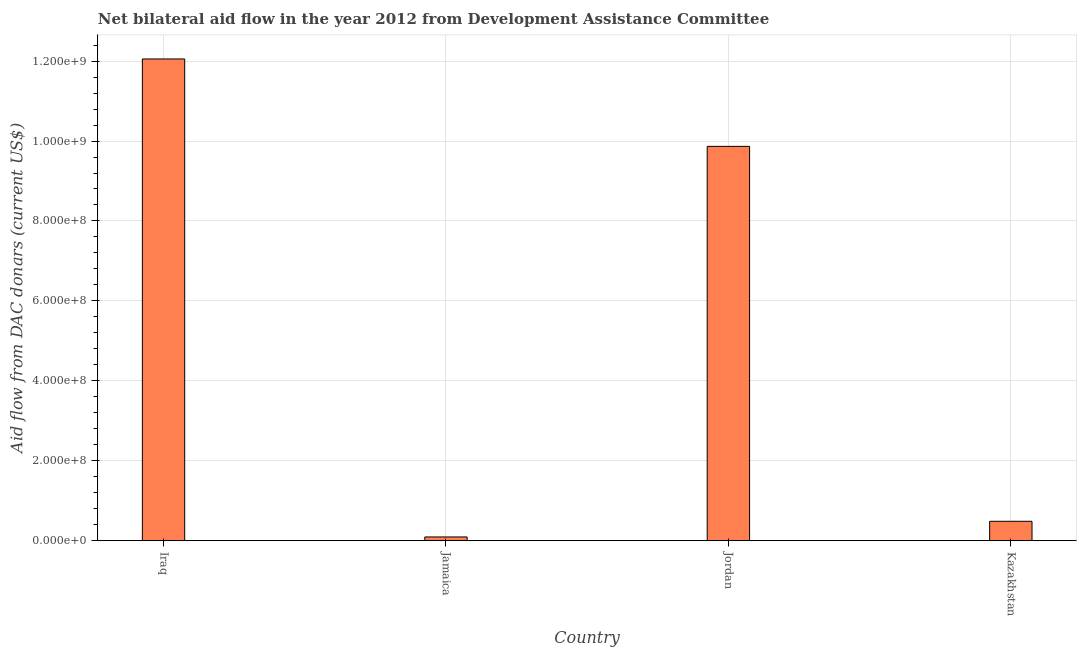Does the graph contain any zero values?
Your response must be concise. No. Does the graph contain grids?
Your response must be concise. Yes. What is the title of the graph?
Give a very brief answer. Net bilateral aid flow in the year 2012 from Development Assistance Committee. What is the label or title of the Y-axis?
Your answer should be very brief. Aid flow from DAC donars (current US$). What is the net bilateral aid flows from dac donors in Iraq?
Your answer should be compact. 1.21e+09. Across all countries, what is the maximum net bilateral aid flows from dac donors?
Your answer should be very brief. 1.21e+09. Across all countries, what is the minimum net bilateral aid flows from dac donors?
Provide a short and direct response. 9.43e+06. In which country was the net bilateral aid flows from dac donors maximum?
Offer a terse response. Iraq. In which country was the net bilateral aid flows from dac donors minimum?
Make the answer very short. Jamaica. What is the sum of the net bilateral aid flows from dac donors?
Provide a short and direct response. 2.25e+09. What is the difference between the net bilateral aid flows from dac donors in Jamaica and Kazakhstan?
Provide a succinct answer. -3.92e+07. What is the average net bilateral aid flows from dac donors per country?
Your answer should be compact. 5.63e+08. What is the median net bilateral aid flows from dac donors?
Offer a very short reply. 5.18e+08. What is the ratio of the net bilateral aid flows from dac donors in Jamaica to that in Kazakhstan?
Keep it short and to the point. 0.19. What is the difference between the highest and the second highest net bilateral aid flows from dac donors?
Ensure brevity in your answer.  2.19e+08. What is the difference between the highest and the lowest net bilateral aid flows from dac donors?
Your answer should be very brief. 1.20e+09. How many bars are there?
Provide a short and direct response. 4. Are all the bars in the graph horizontal?
Your answer should be very brief. No. How many countries are there in the graph?
Keep it short and to the point. 4. What is the difference between two consecutive major ticks on the Y-axis?
Provide a short and direct response. 2.00e+08. Are the values on the major ticks of Y-axis written in scientific E-notation?
Make the answer very short. Yes. What is the Aid flow from DAC donars (current US$) in Iraq?
Keep it short and to the point. 1.21e+09. What is the Aid flow from DAC donars (current US$) in Jamaica?
Your answer should be very brief. 9.43e+06. What is the Aid flow from DAC donars (current US$) of Jordan?
Ensure brevity in your answer.  9.87e+08. What is the Aid flow from DAC donars (current US$) in Kazakhstan?
Give a very brief answer. 4.86e+07. What is the difference between the Aid flow from DAC donars (current US$) in Iraq and Jamaica?
Give a very brief answer. 1.20e+09. What is the difference between the Aid flow from DAC donars (current US$) in Iraq and Jordan?
Provide a short and direct response. 2.19e+08. What is the difference between the Aid flow from DAC donars (current US$) in Iraq and Kazakhstan?
Keep it short and to the point. 1.16e+09. What is the difference between the Aid flow from DAC donars (current US$) in Jamaica and Jordan?
Provide a succinct answer. -9.77e+08. What is the difference between the Aid flow from DAC donars (current US$) in Jamaica and Kazakhstan?
Offer a very short reply. -3.92e+07. What is the difference between the Aid flow from DAC donars (current US$) in Jordan and Kazakhstan?
Your answer should be very brief. 9.38e+08. What is the ratio of the Aid flow from DAC donars (current US$) in Iraq to that in Jamaica?
Your response must be concise. 127.82. What is the ratio of the Aid flow from DAC donars (current US$) in Iraq to that in Jordan?
Give a very brief answer. 1.22. What is the ratio of the Aid flow from DAC donars (current US$) in Iraq to that in Kazakhstan?
Provide a short and direct response. 24.79. What is the ratio of the Aid flow from DAC donars (current US$) in Jamaica to that in Jordan?
Provide a succinct answer. 0.01. What is the ratio of the Aid flow from DAC donars (current US$) in Jamaica to that in Kazakhstan?
Offer a very short reply. 0.19. What is the ratio of the Aid flow from DAC donars (current US$) in Jordan to that in Kazakhstan?
Make the answer very short. 20.29. 